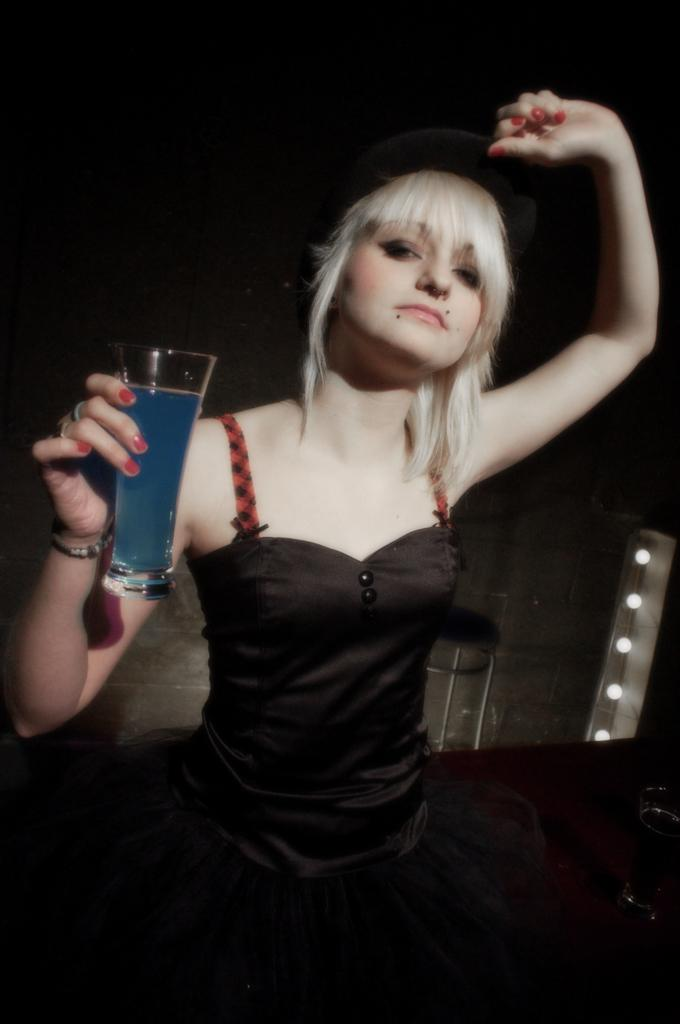What is the main subject of the image? The main subject of the image is a woman standing in the middle of the image. What is the woman holding in the image? The woman is holding a glass. What can be seen behind the woman in the image? There is a wall visible behind the woman. What flavor of ant can be seen crawling on the woman's shoulder in the image? There are no ants present in the image, let alone any specific flavor of ants. 